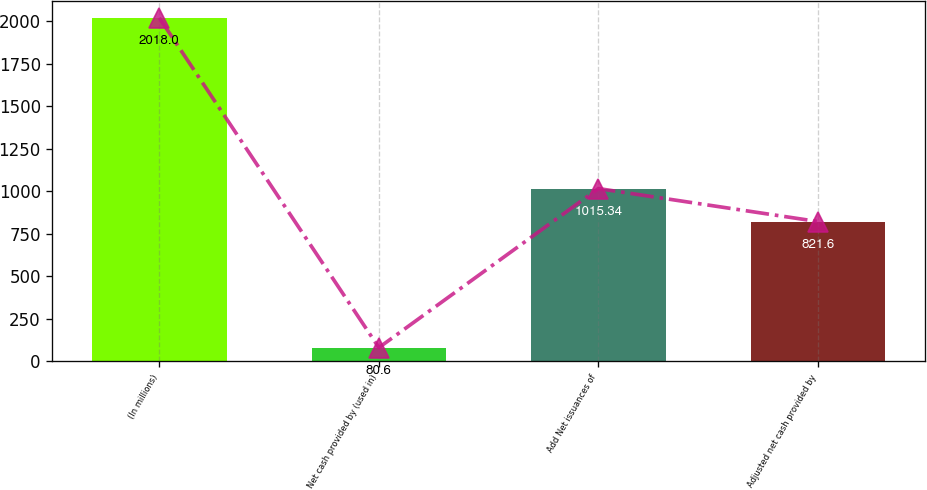Convert chart to OTSL. <chart><loc_0><loc_0><loc_500><loc_500><bar_chart><fcel>(In millions)<fcel>Net cash provided by (used in)<fcel>Add Net issuances of<fcel>Adjusted net cash provided by<nl><fcel>2018<fcel>80.6<fcel>1015.34<fcel>821.6<nl></chart> 